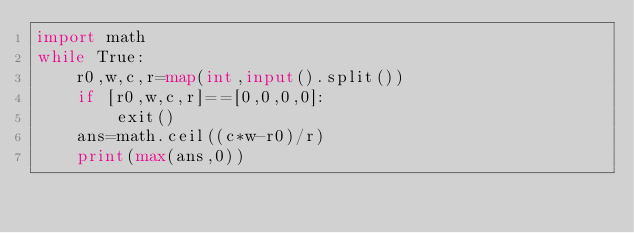Convert code to text. <code><loc_0><loc_0><loc_500><loc_500><_Python_>import math
while True:
	r0,w,c,r=map(int,input().split())
	if [r0,w,c,r]==[0,0,0,0]:
		exit()
	ans=math.ceil((c*w-r0)/r)
	print(max(ans,0))
</code> 